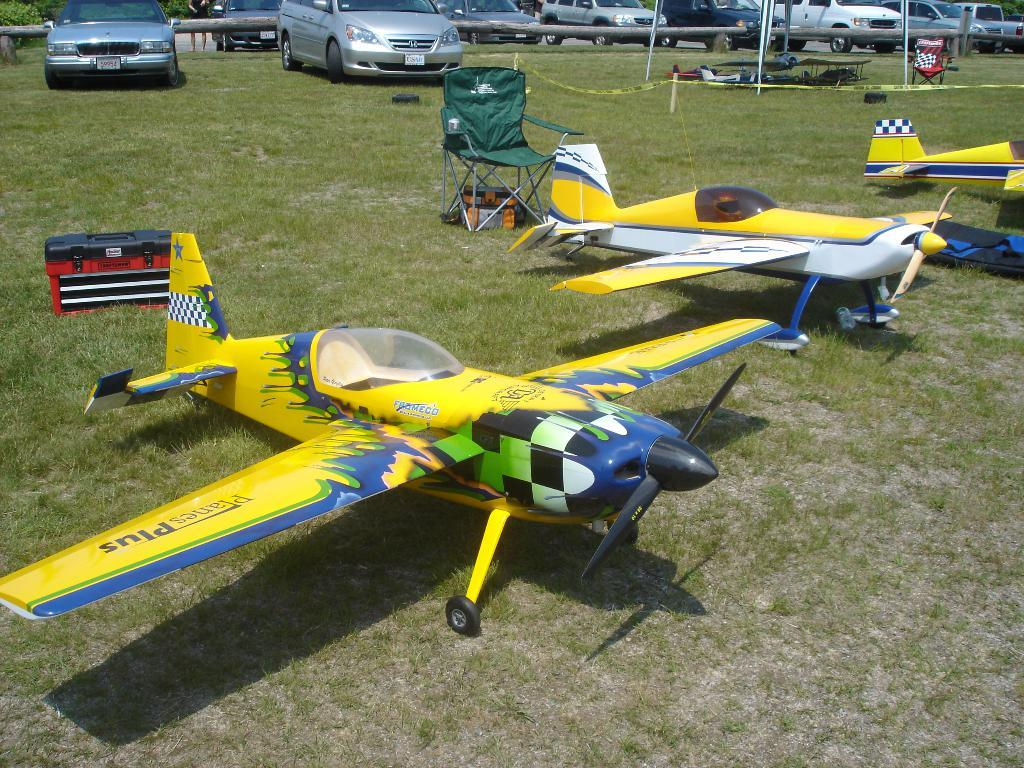What type of furniture is present in the image? There are chairs in the image. What other objects can be seen in the image? There is a box and replica airplanes in the image. Where are these objects located? These objects are on the grass. What can be seen in the background of the image? There are cars visible in the background of the image. What type of legal advice is the grandmother providing at the station in the image? There is no grandmother, legal advice, or station present in the image. 